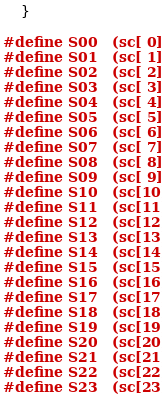<code> <loc_0><loc_0><loc_500><loc_500><_Cuda_>	}

#define S00   (sc[ 0])
#define S01   (sc[ 1])
#define S02   (sc[ 2])
#define S03   (sc[ 3])
#define S04   (sc[ 4])
#define S05   (sc[ 5])
#define S06   (sc[ 6])
#define S07   (sc[ 7])
#define S08   (sc[ 8])
#define S09   (sc[ 9])
#define S10   (sc[10])
#define S11   (sc[11])
#define S12   (sc[12])
#define S13   (sc[13])
#define S14   (sc[14])
#define S15   (sc[15])
#define S16   (sc[16])
#define S17   (sc[17])
#define S18   (sc[18])
#define S19   (sc[19])
#define S20   (sc[20])
#define S21   (sc[21])
#define S22   (sc[22])
#define S23   (sc[23])</code> 